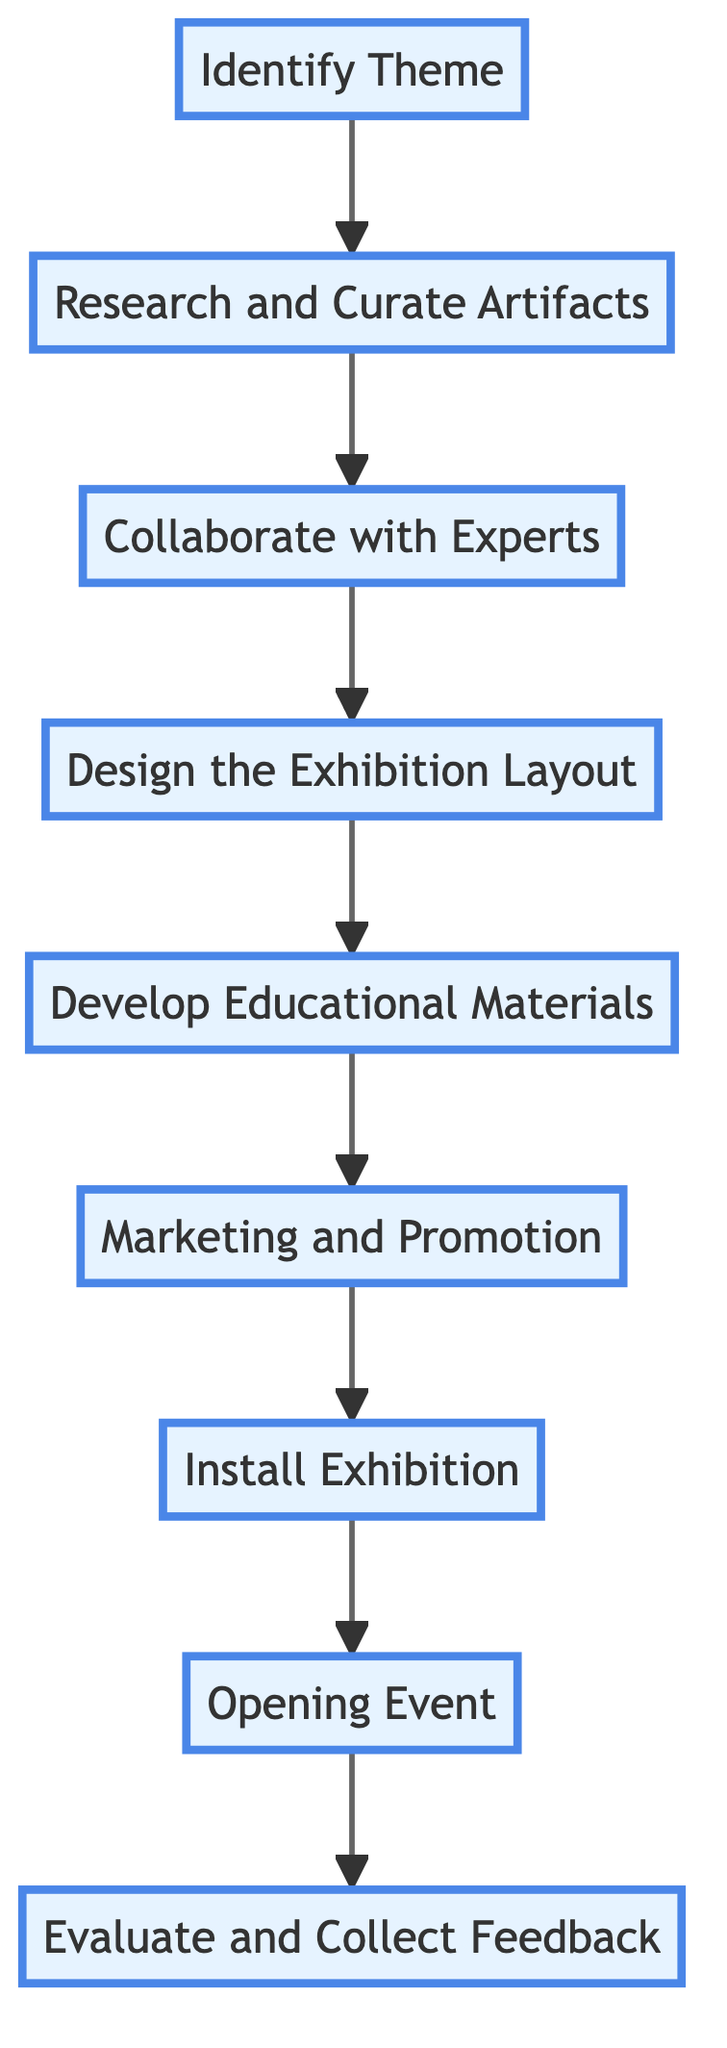What is the first step in organizing the exhibition? The first node in the diagram is "Identify Theme." This is the starting point for the flow and indicates that selecting a cultural theme is the initial step in organizing the exhibition.
Answer: Identify Theme How many steps are in the process? There are a total of nine nodes in the flowchart, each representing a step in the process of organizing the thematic cultural exhibition.
Answer: Nine What comes after "Collaborate with Experts"? The flowchart shows that the step after "Collaborate with Experts" is "Design the Exhibition Layout." This indicates the sequential order of activities in the process.
Answer: Design the Exhibition Layout Which step involves working with historians? The step "Collaborate with Experts" explicitly mentions working with historians, cultural experts, and other academics as part of the process to organize the exhibition.
Answer: Collaborate with Experts Which two steps are immediately connected in the workflow? The flowchart shows several pairs of directly connected steps. Notably, "Research and Curate Artifacts" is immediately followed by "Collaborate with Experts," indicating a direct connection in the workflow.
Answer: Research and Curate Artifacts and Collaborate with Experts What type of materials should be developed to enhance visitor experience? The diagram outlines that "Develop Educational Materials" is a crucial step in the process, emphasizing the need to prepare guides and multimedia content aimed at enhancing the visitor experience.
Answer: Develop Educational Materials How does the evaluation process occur in this flowchart? At the end of the flowchart, "Evaluate and Collect Feedback" represents the final step in the process, indicating that after the exhibition has been opened, the organizers will gather visitor feedback and evaluate the exhibition's success.
Answer: Evaluate and Collect Feedback What is the last step of the exhibition organization process? According to the flowchart, "Evaluate and Collect Feedback" is the last node, which suggests that this is the final step after opening the exhibition to assess its impact and success accordingly.
Answer: Evaluate and Collect Feedback Which step directly precedes the opening event? The flowchart indicates that "Install Exhibition" comes directly before the "Opening Event," showing the preparation leading up to the exhibition's launch.
Answer: Install Exhibition 